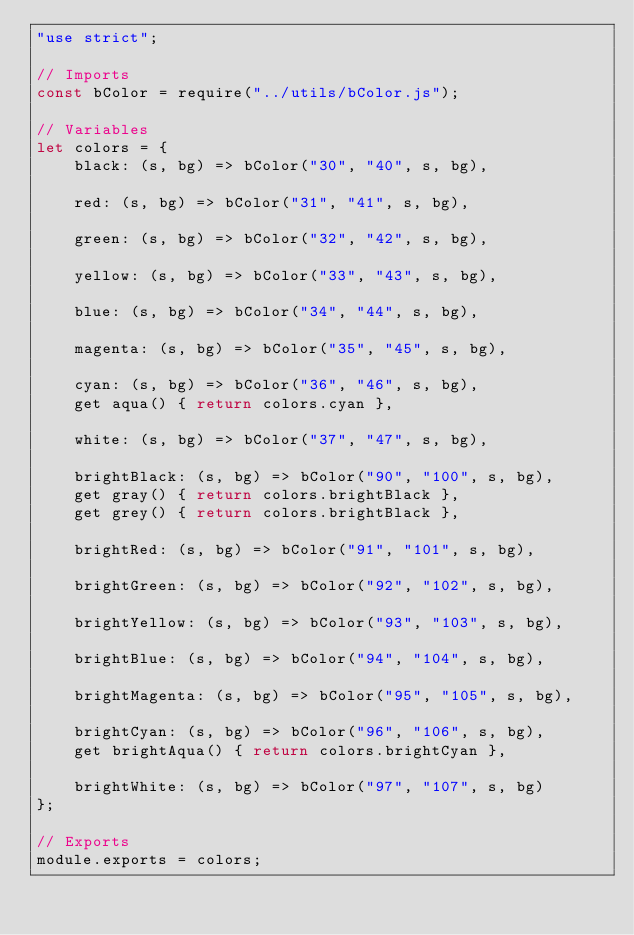Convert code to text. <code><loc_0><loc_0><loc_500><loc_500><_JavaScript_>"use strict";

// Imports
const bColor = require("../utils/bColor.js");

// Variables
let colors = {
    black: (s, bg) => bColor("30", "40", s, bg),

    red: (s, bg) => bColor("31", "41", s, bg),

    green: (s, bg) => bColor("32", "42", s, bg),

    yellow: (s, bg) => bColor("33", "43", s, bg),

    blue: (s, bg) => bColor("34", "44", s, bg),

    magenta: (s, bg) => bColor("35", "45", s, bg),

    cyan: (s, bg) => bColor("36", "46", s, bg),
    get aqua() { return colors.cyan },

    white: (s, bg) => bColor("37", "47", s, bg),

    brightBlack: (s, bg) => bColor("90", "100", s, bg),
    get gray() { return colors.brightBlack },
    get grey() { return colors.brightBlack },

    brightRed: (s, bg) => bColor("91", "101", s, bg),

    brightGreen: (s, bg) => bColor("92", "102", s, bg),

    brightYellow: (s, bg) => bColor("93", "103", s, bg),

    brightBlue: (s, bg) => bColor("94", "104", s, bg),

    brightMagenta: (s, bg) => bColor("95", "105", s, bg),

    brightCyan: (s, bg) => bColor("96", "106", s, bg),
    get brightAqua() { return colors.brightCyan },

    brightWhite: (s, bg) => bColor("97", "107", s, bg)
};

// Exports
module.exports = colors;</code> 